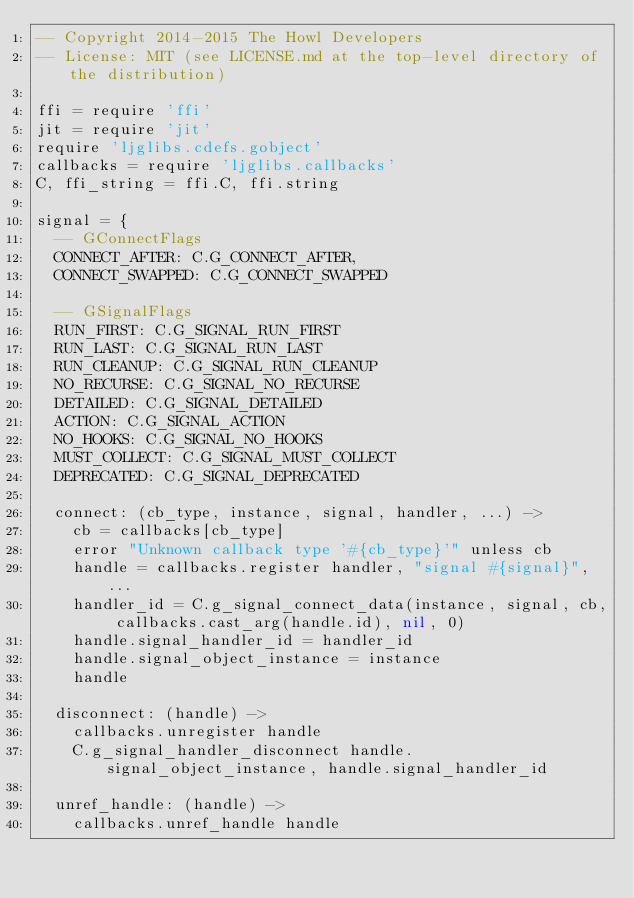Convert code to text. <code><loc_0><loc_0><loc_500><loc_500><_MoonScript_>-- Copyright 2014-2015 The Howl Developers
-- License: MIT (see LICENSE.md at the top-level directory of the distribution)

ffi = require 'ffi'
jit = require 'jit'
require 'ljglibs.cdefs.gobject'
callbacks = require 'ljglibs.callbacks'
C, ffi_string = ffi.C, ffi.string

signal = {
  -- GConnectFlags
  CONNECT_AFTER: C.G_CONNECT_AFTER,
  CONNECT_SWAPPED: C.G_CONNECT_SWAPPED

  -- GSignalFlags
  RUN_FIRST: C.G_SIGNAL_RUN_FIRST
  RUN_LAST: C.G_SIGNAL_RUN_LAST
  RUN_CLEANUP: C.G_SIGNAL_RUN_CLEANUP
  NO_RECURSE: C.G_SIGNAL_NO_RECURSE
  DETAILED: C.G_SIGNAL_DETAILED
  ACTION: C.G_SIGNAL_ACTION
  NO_HOOKS: C.G_SIGNAL_NO_HOOKS
  MUST_COLLECT: C.G_SIGNAL_MUST_COLLECT
  DEPRECATED: C.G_SIGNAL_DEPRECATED

  connect: (cb_type, instance, signal, handler, ...) ->
    cb = callbacks[cb_type]
    error "Unknown callback type '#{cb_type}'" unless cb
    handle = callbacks.register handler, "signal #{signal}", ...
    handler_id = C.g_signal_connect_data(instance, signal, cb, callbacks.cast_arg(handle.id), nil, 0)
    handle.signal_handler_id = handler_id
    handle.signal_object_instance = instance
    handle

  disconnect: (handle) ->
    callbacks.unregister handle
    C.g_signal_handler_disconnect handle.signal_object_instance, handle.signal_handler_id

  unref_handle: (handle) ->
    callbacks.unref_handle handle
</code> 